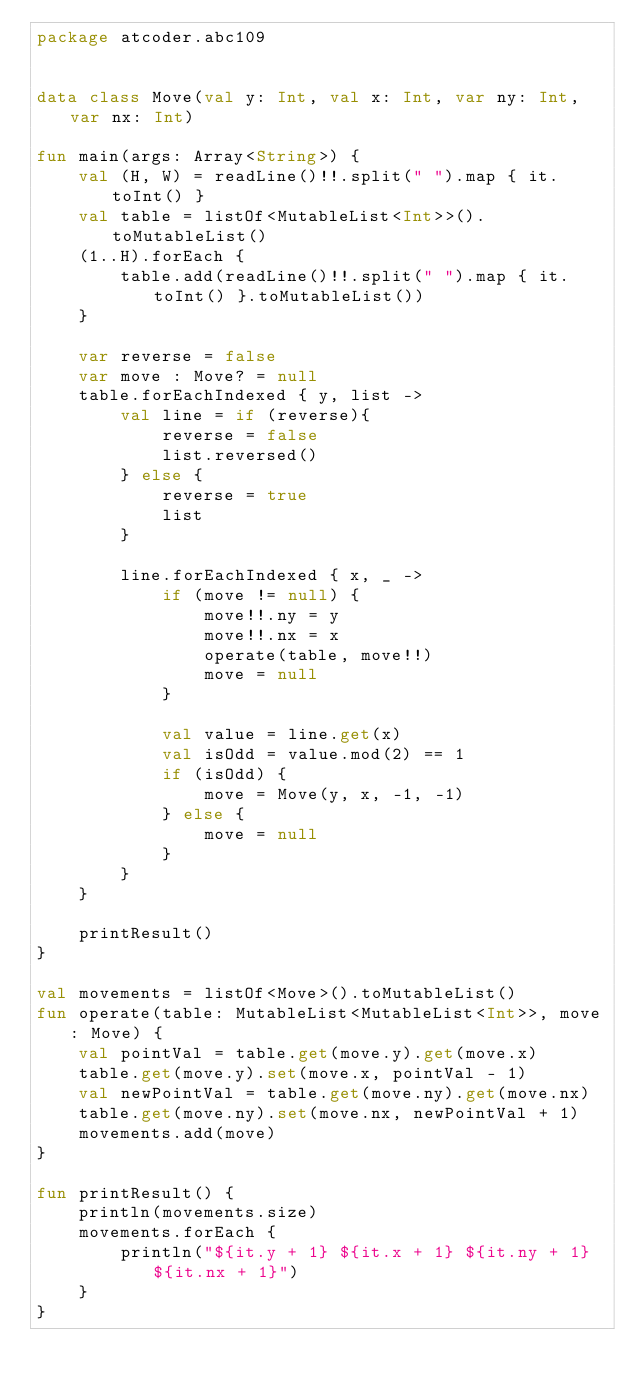Convert code to text. <code><loc_0><loc_0><loc_500><loc_500><_Kotlin_>package atcoder.abc109


data class Move(val y: Int, val x: Int, var ny: Int, var nx: Int)

fun main(args: Array<String>) {
    val (H, W) = readLine()!!.split(" ").map { it.toInt() }
    val table = listOf<MutableList<Int>>().toMutableList()
    (1..H).forEach {
        table.add(readLine()!!.split(" ").map { it.toInt() }.toMutableList())
    }

    var reverse = false
    var move : Move? = null
    table.forEachIndexed { y, list ->
        val line = if (reverse){
            reverse = false
            list.reversed()
        } else {
            reverse = true
            list
        }

        line.forEachIndexed { x, _ ->
            if (move != null) {
                move!!.ny = y
                move!!.nx = x
                operate(table, move!!)
                move = null
            }

            val value = line.get(x)
            val isOdd = value.mod(2) == 1
            if (isOdd) {
                move = Move(y, x, -1, -1)
            } else {
                move = null
            }
        }
    }

    printResult()
}

val movements = listOf<Move>().toMutableList()
fun operate(table: MutableList<MutableList<Int>>, move: Move) {
    val pointVal = table.get(move.y).get(move.x)
    table.get(move.y).set(move.x, pointVal - 1)
    val newPointVal = table.get(move.ny).get(move.nx)
    table.get(move.ny).set(move.nx, newPointVal + 1)
    movements.add(move)
}

fun printResult() {
    println(movements.size)
    movements.forEach {
        println("${it.y + 1} ${it.x + 1} ${it.ny + 1} ${it.nx + 1}")
    }
}
</code> 